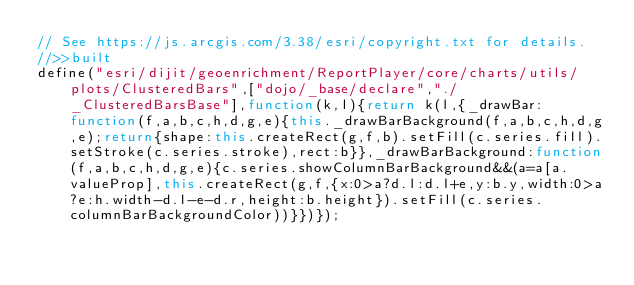Convert code to text. <code><loc_0><loc_0><loc_500><loc_500><_JavaScript_>// See https://js.arcgis.com/3.38/esri/copyright.txt for details.
//>>built
define("esri/dijit/geoenrichment/ReportPlayer/core/charts/utils/plots/ClusteredBars",["dojo/_base/declare","./_ClusteredBarsBase"],function(k,l){return k(l,{_drawBar:function(f,a,b,c,h,d,g,e){this._drawBarBackground(f,a,b,c,h,d,g,e);return{shape:this.createRect(g,f,b).setFill(c.series.fill).setStroke(c.series.stroke),rect:b}},_drawBarBackground:function(f,a,b,c,h,d,g,e){c.series.showColumnBarBackground&&(a=a[a.valueProp],this.createRect(g,f,{x:0>a?d.l:d.l+e,y:b.y,width:0>a?e:h.width-d.l-e-d.r,height:b.height}).setFill(c.series.columnBarBackgroundColor))}})});</code> 